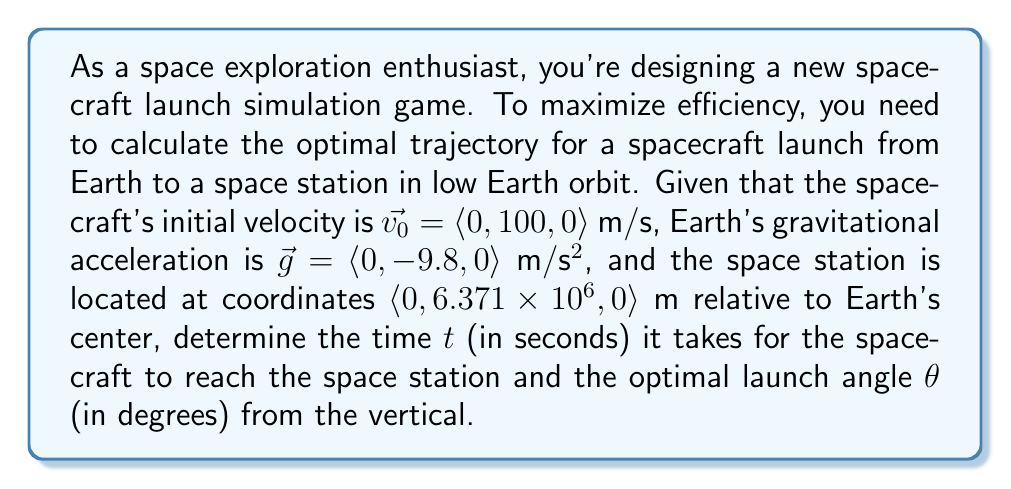Teach me how to tackle this problem. To solve this problem, we'll use vector calculus and projectile motion equations. Let's break it down step by step:

1) The position vector of the spacecraft at time $t$ is given by:
   $$\vec{r}(t) = \vec{r_0} + \vec{v_0}t + \frac{1}{2}\vec{g}t^2$$

2) Since we're launching from Earth's surface, $\vec{r_0} = \langle 0, R_E, 0 \rangle$, where $R_E$ is Earth's radius (approximately $6.371 \times 10^6$ m).

3) Substituting the given values:
   $$\vec{r}(t) = \langle 0, 6.371 \times 10^6, 0 \rangle + \langle 0, 100t, 0 \rangle + \frac{1}{2}\langle 0, -9.8t^2, 0 \rangle$$

4) Simplifying:
   $$\vec{r}(t) = \langle 0, 6.371 \times 10^6 + 100t - 4.9t^2, 0 \rangle$$

5) The spacecraft reaches the space station when its y-coordinate equals the station's y-coordinate:
   $$6.371 \times 10^6 + 100t - 4.9t^2 = 6.371 \times 10^6$$

6) Simplifying:
   $$100t - 4.9t^2 = 0$$
   $$t(100 - 4.9t) = 0$$

7) Solving this quadratic equation:
   $$t = 0$$ or $$t = \frac{100}{4.9} \approx 20.41$$ seconds

8) The non-zero solution is the time it takes to reach the space station.

9) To find the optimal launch angle, we use the velocity vector at launch:
   $$\vec{v_0} = \langle 0, 100, 0 \rangle$$

10) The angle between this vector and the vertical (y-axis) is:
    $$\theta = \arctan\left(\frac{\text{horizontal component}}{\text{vertical component}}\right) = \arctan\left(\frac{0}{100}\right) = 0°$$

Therefore, the optimal launch angle is 0° from the vertical, meaning a straight vertical launch.
Answer: Time to reach the space station: $t \approx 20.41$ seconds
Optimal launch angle: $\theta = 0°$ from the vertical 